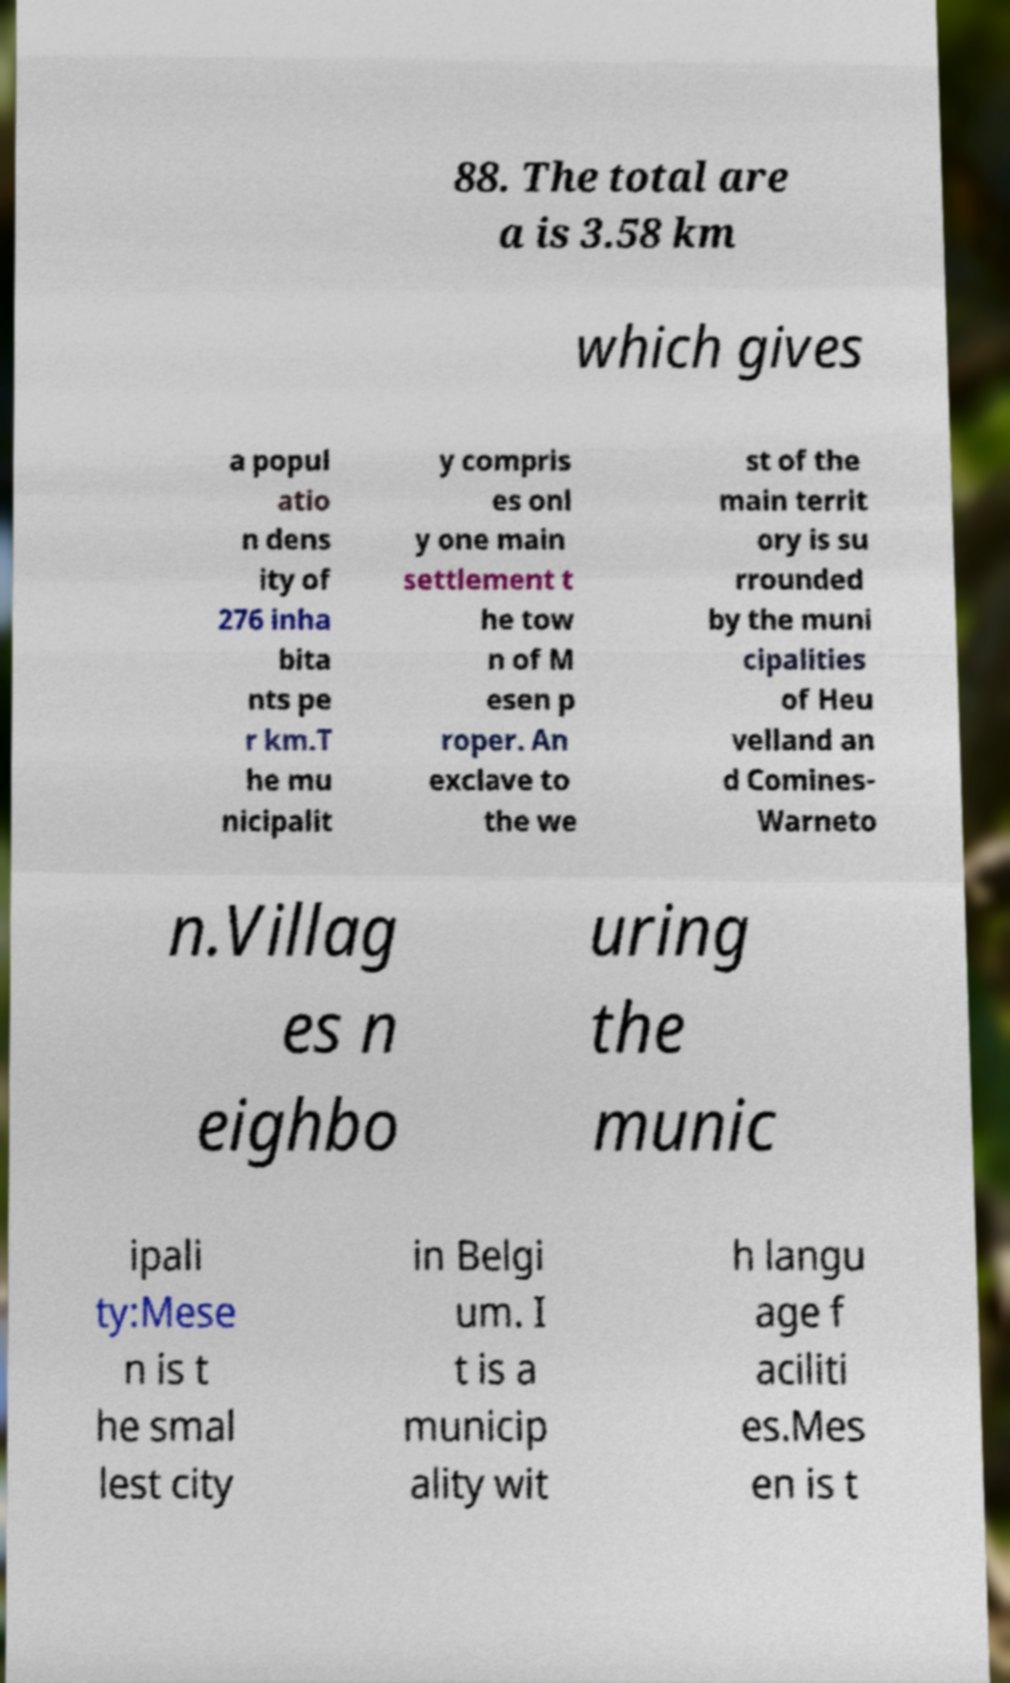Can you accurately transcribe the text from the provided image for me? 88. The total are a is 3.58 km which gives a popul atio n dens ity of 276 inha bita nts pe r km.T he mu nicipalit y compris es onl y one main settlement t he tow n of M esen p roper. An exclave to the we st of the main territ ory is su rrounded by the muni cipalities of Heu velland an d Comines- Warneto n.Villag es n eighbo uring the munic ipali ty:Mese n is t he smal lest city in Belgi um. I t is a municip ality wit h langu age f aciliti es.Mes en is t 